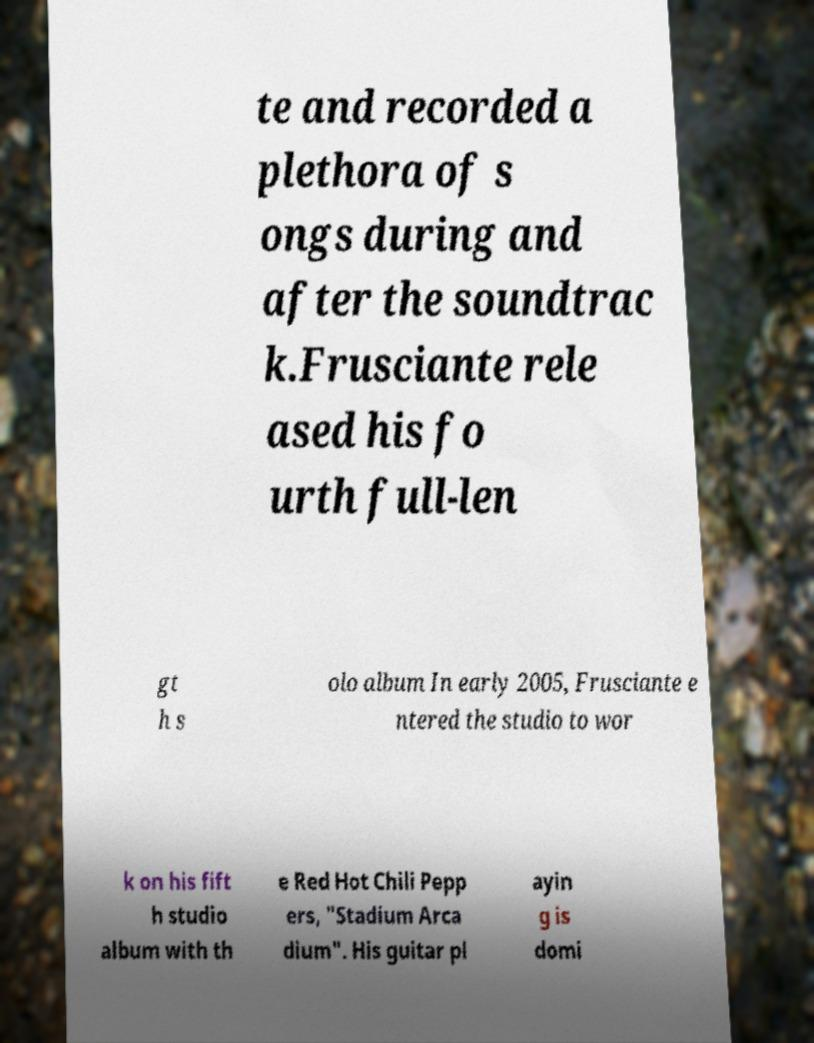Can you accurately transcribe the text from the provided image for me? te and recorded a plethora of s ongs during and after the soundtrac k.Frusciante rele ased his fo urth full-len gt h s olo album In early 2005, Frusciante e ntered the studio to wor k on his fift h studio album with th e Red Hot Chili Pepp ers, "Stadium Arca dium". His guitar pl ayin g is domi 